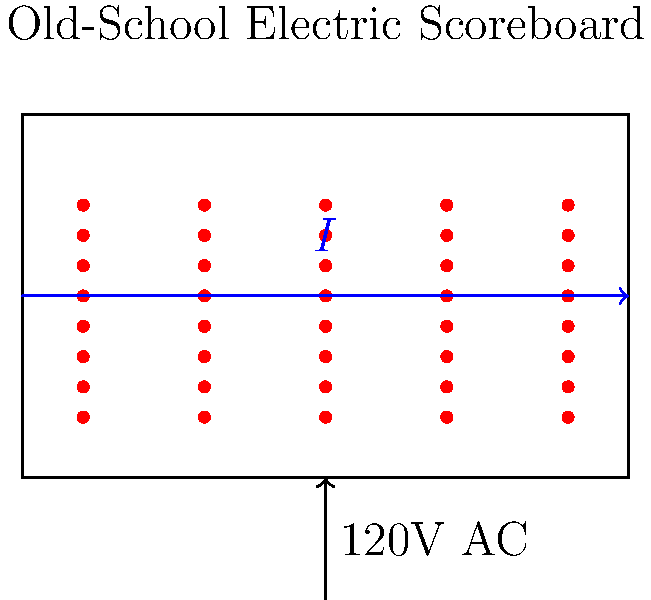An old-school electric scoreboard at Albion College's football stadium from the late 1940s uses 40 identical incandescent light bulbs, each rated at 25 watts and 120 volts. If the scoreboard operates on a 120V AC power supply, calculate the total current drawn by the scoreboard when all bulbs are lit. To solve this problem, we'll follow these steps:

1) First, recall that Power (P) = Voltage (V) × Current (I)

2) We know the power and voltage for each bulb:
   P = 25 W
   V = 120 V

3) We can calculate the current for one bulb using:
   I = P / V = 25 W / 120 V = 0.2083 A

4) There are 40 identical bulbs, so the total current will be 40 times the current of one bulb:
   I_total = 40 × 0.2083 A = 8.333 A

5) Alternatively, we could have calculated the total power first:
   P_total = 40 × 25 W = 1000 W

   And then used this to find the total current:
   I_total = P_total / V = 1000 W / 120 V = 8.333 A

6) Rounding to two decimal places for practical purposes:
   I_total ≈ 8.33 A

This current draw would have been significant for a scoreboard in the late 1940s, highlighting the energy efficiency improvements in modern LED scoreboards.
Answer: 8.33 A 